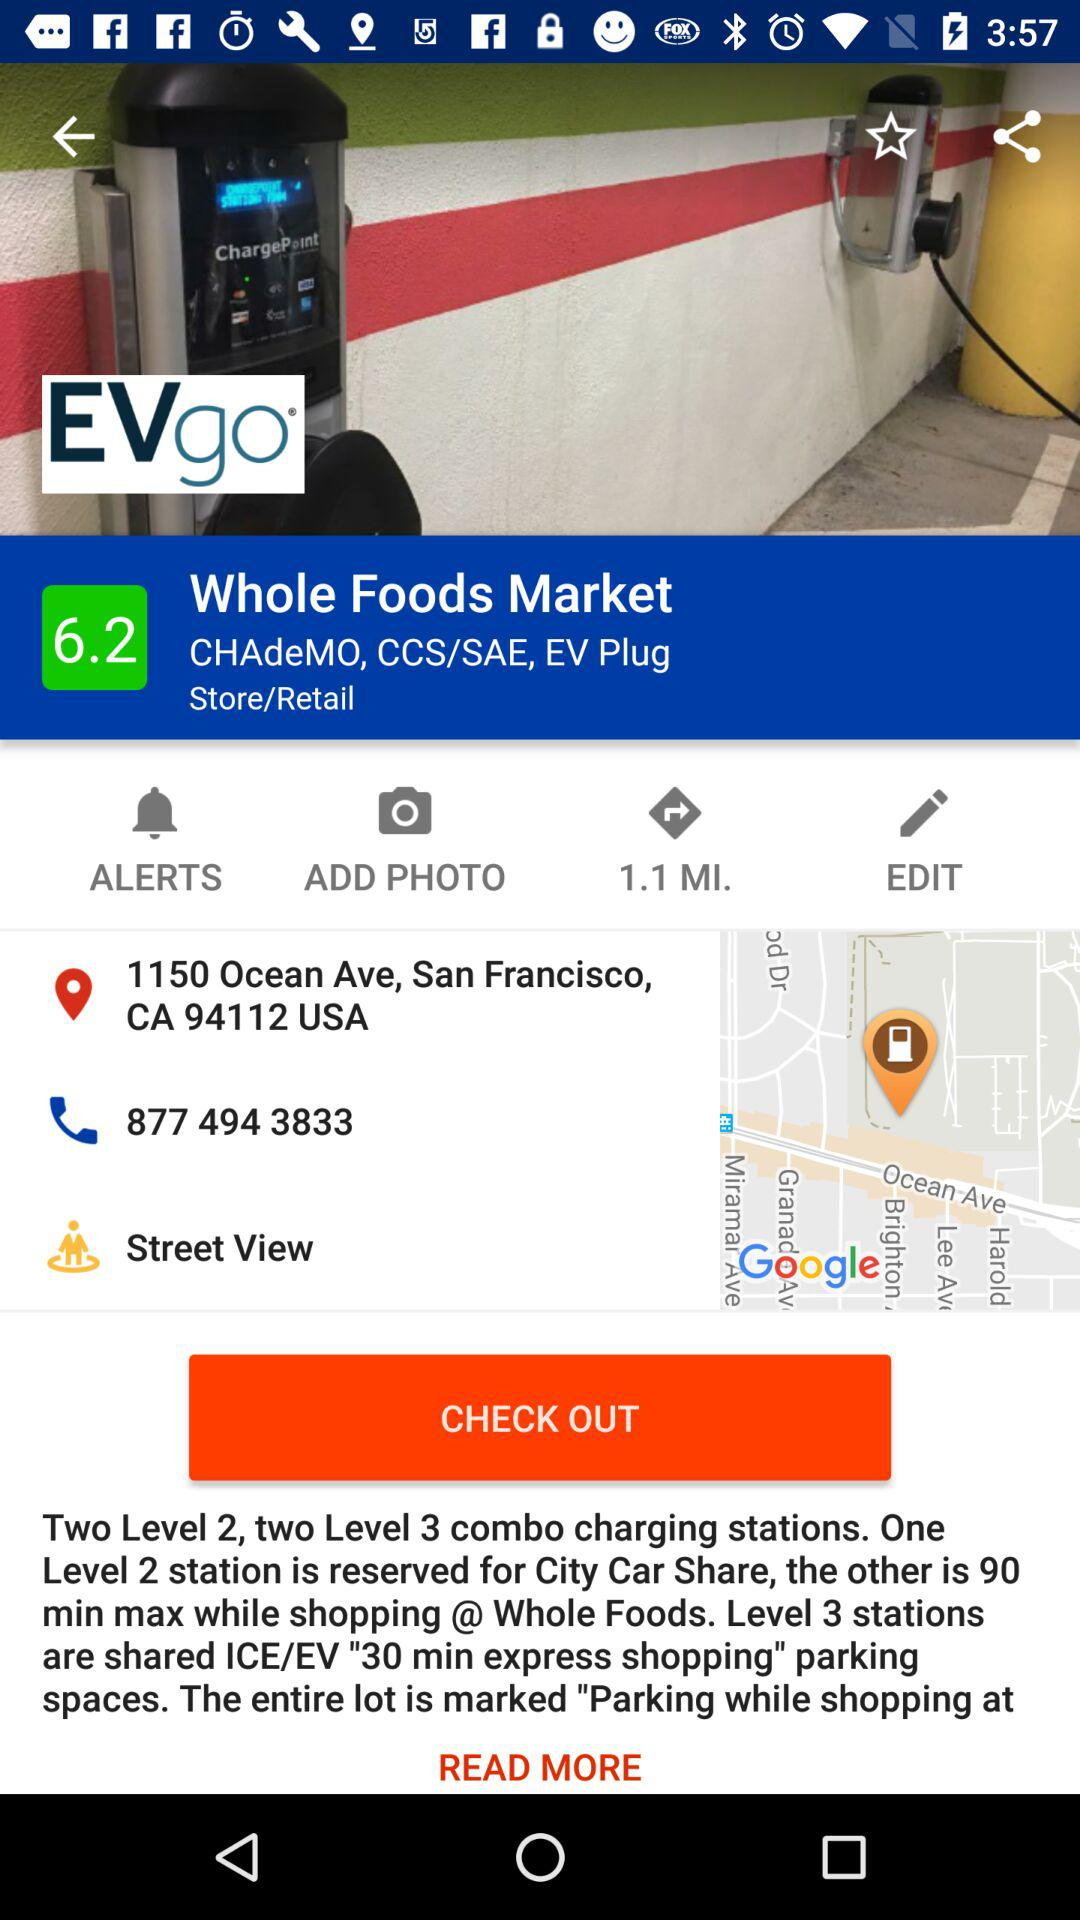What is the address of "EVgo"? The address is 1150 Ocean Ave, San Francisco, CA 94112 USA. 